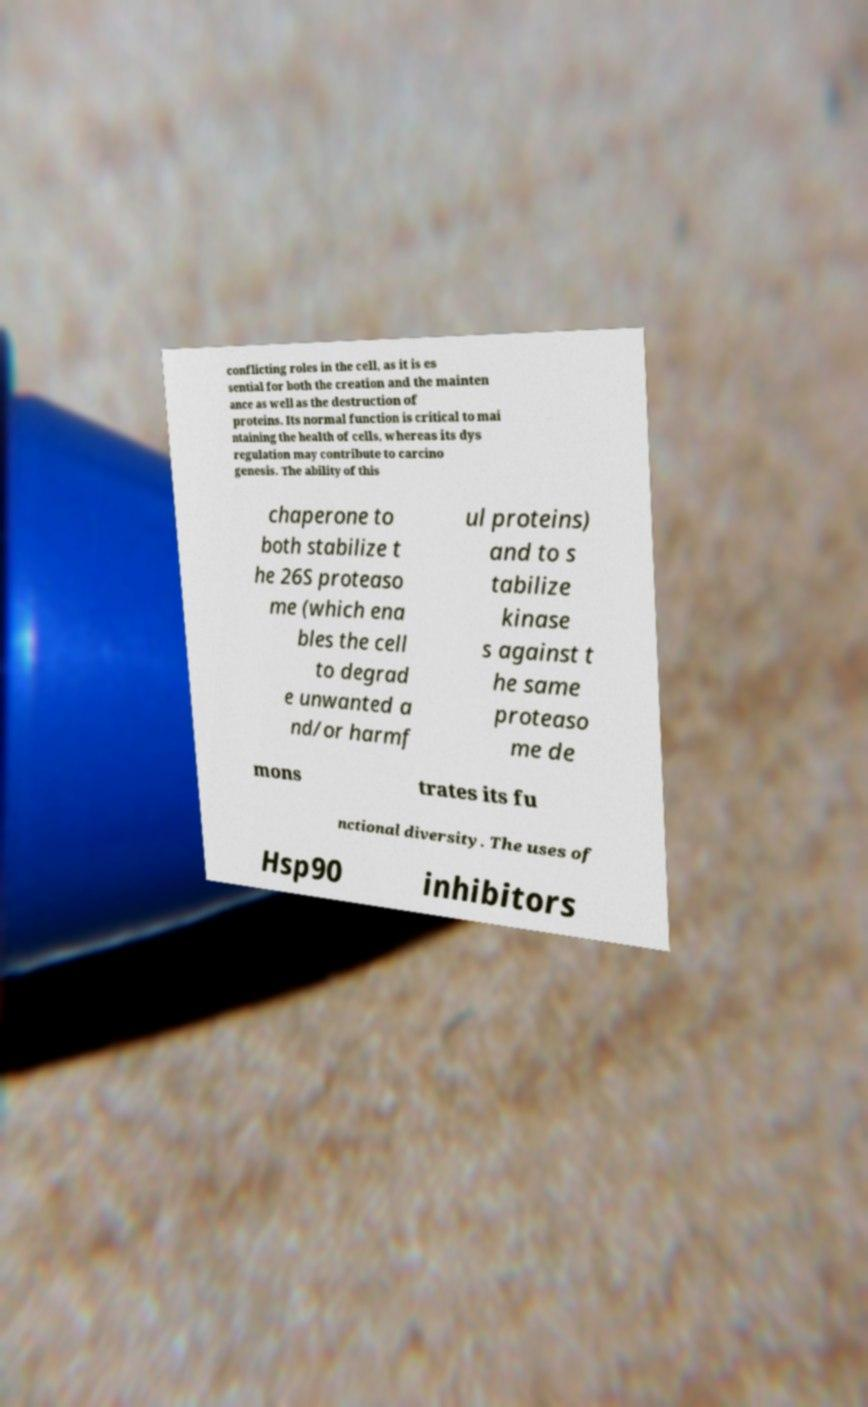Can you accurately transcribe the text from the provided image for me? conflicting roles in the cell, as it is es sential for both the creation and the mainten ance as well as the destruction of proteins. Its normal function is critical to mai ntaining the health of cells, whereas its dys regulation may contribute to carcino genesis. The ability of this chaperone to both stabilize t he 26S proteaso me (which ena bles the cell to degrad e unwanted a nd/or harmf ul proteins) and to s tabilize kinase s against t he same proteaso me de mons trates its fu nctional diversity. The uses of Hsp90 inhibitors 